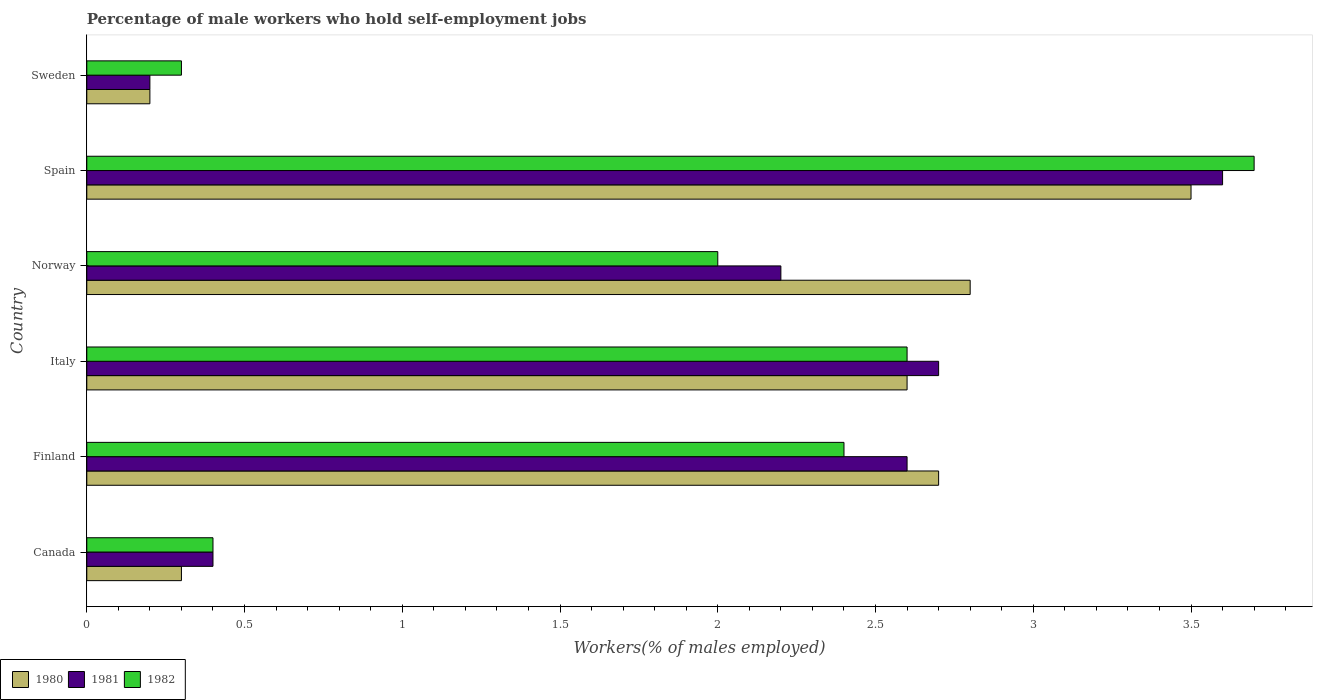How many groups of bars are there?
Give a very brief answer. 6. Are the number of bars per tick equal to the number of legend labels?
Ensure brevity in your answer.  Yes. How many bars are there on the 4th tick from the bottom?
Offer a very short reply. 3. Across all countries, what is the minimum percentage of self-employed male workers in 1980?
Your response must be concise. 0.2. In which country was the percentage of self-employed male workers in 1982 maximum?
Offer a very short reply. Spain. What is the total percentage of self-employed male workers in 1981 in the graph?
Keep it short and to the point. 11.7. What is the difference between the percentage of self-employed male workers in 1980 in Norway and that in Sweden?
Offer a terse response. 2.6. What is the difference between the percentage of self-employed male workers in 1981 in Canada and the percentage of self-employed male workers in 1980 in Sweden?
Your response must be concise. 0.2. What is the average percentage of self-employed male workers in 1981 per country?
Give a very brief answer. 1.95. What is the difference between the percentage of self-employed male workers in 1980 and percentage of self-employed male workers in 1981 in Norway?
Your answer should be very brief. 0.6. In how many countries, is the percentage of self-employed male workers in 1980 greater than 3.6 %?
Keep it short and to the point. 0. What is the ratio of the percentage of self-employed male workers in 1982 in Finland to that in Norway?
Keep it short and to the point. 1.2. What is the difference between the highest and the second highest percentage of self-employed male workers in 1981?
Give a very brief answer. 0.9. What is the difference between the highest and the lowest percentage of self-employed male workers in 1982?
Ensure brevity in your answer.  3.4. In how many countries, is the percentage of self-employed male workers in 1981 greater than the average percentage of self-employed male workers in 1981 taken over all countries?
Your answer should be very brief. 4. What does the 2nd bar from the bottom in Spain represents?
Give a very brief answer. 1981. Is it the case that in every country, the sum of the percentage of self-employed male workers in 1982 and percentage of self-employed male workers in 1980 is greater than the percentage of self-employed male workers in 1981?
Offer a very short reply. Yes. How many bars are there?
Your answer should be very brief. 18. Are all the bars in the graph horizontal?
Keep it short and to the point. Yes. What is the difference between two consecutive major ticks on the X-axis?
Provide a succinct answer. 0.5. Are the values on the major ticks of X-axis written in scientific E-notation?
Ensure brevity in your answer.  No. Does the graph contain any zero values?
Give a very brief answer. No. Where does the legend appear in the graph?
Offer a terse response. Bottom left. How many legend labels are there?
Ensure brevity in your answer.  3. How are the legend labels stacked?
Provide a succinct answer. Horizontal. What is the title of the graph?
Offer a terse response. Percentage of male workers who hold self-employment jobs. Does "1976" appear as one of the legend labels in the graph?
Your answer should be very brief. No. What is the label or title of the X-axis?
Offer a very short reply. Workers(% of males employed). What is the Workers(% of males employed) in 1980 in Canada?
Keep it short and to the point. 0.3. What is the Workers(% of males employed) of 1981 in Canada?
Your answer should be compact. 0.4. What is the Workers(% of males employed) of 1982 in Canada?
Keep it short and to the point. 0.4. What is the Workers(% of males employed) of 1980 in Finland?
Provide a short and direct response. 2.7. What is the Workers(% of males employed) in 1981 in Finland?
Offer a terse response. 2.6. What is the Workers(% of males employed) in 1982 in Finland?
Give a very brief answer. 2.4. What is the Workers(% of males employed) of 1980 in Italy?
Provide a short and direct response. 2.6. What is the Workers(% of males employed) of 1981 in Italy?
Offer a terse response. 2.7. What is the Workers(% of males employed) of 1982 in Italy?
Your answer should be very brief. 2.6. What is the Workers(% of males employed) of 1980 in Norway?
Provide a succinct answer. 2.8. What is the Workers(% of males employed) of 1981 in Norway?
Your answer should be very brief. 2.2. What is the Workers(% of males employed) of 1982 in Norway?
Make the answer very short. 2. What is the Workers(% of males employed) of 1980 in Spain?
Provide a succinct answer. 3.5. What is the Workers(% of males employed) in 1981 in Spain?
Offer a very short reply. 3.6. What is the Workers(% of males employed) in 1982 in Spain?
Give a very brief answer. 3.7. What is the Workers(% of males employed) of 1980 in Sweden?
Your answer should be very brief. 0.2. What is the Workers(% of males employed) of 1981 in Sweden?
Offer a very short reply. 0.2. What is the Workers(% of males employed) in 1982 in Sweden?
Your answer should be very brief. 0.3. Across all countries, what is the maximum Workers(% of males employed) in 1981?
Your answer should be very brief. 3.6. Across all countries, what is the maximum Workers(% of males employed) of 1982?
Keep it short and to the point. 3.7. Across all countries, what is the minimum Workers(% of males employed) in 1980?
Give a very brief answer. 0.2. Across all countries, what is the minimum Workers(% of males employed) of 1981?
Provide a short and direct response. 0.2. Across all countries, what is the minimum Workers(% of males employed) in 1982?
Keep it short and to the point. 0.3. What is the total Workers(% of males employed) in 1980 in the graph?
Give a very brief answer. 12.1. What is the total Workers(% of males employed) of 1982 in the graph?
Your response must be concise. 11.4. What is the difference between the Workers(% of males employed) of 1980 in Canada and that in Finland?
Offer a very short reply. -2.4. What is the difference between the Workers(% of males employed) of 1982 in Canada and that in Finland?
Your response must be concise. -2. What is the difference between the Workers(% of males employed) of 1981 in Canada and that in Italy?
Keep it short and to the point. -2.3. What is the difference between the Workers(% of males employed) of 1981 in Canada and that in Norway?
Give a very brief answer. -1.8. What is the difference between the Workers(% of males employed) of 1982 in Canada and that in Norway?
Your response must be concise. -1.6. What is the difference between the Workers(% of males employed) of 1980 in Canada and that in Spain?
Keep it short and to the point. -3.2. What is the difference between the Workers(% of males employed) in 1980 in Finland and that in Italy?
Provide a succinct answer. 0.1. What is the difference between the Workers(% of males employed) in 1981 in Finland and that in Italy?
Provide a succinct answer. -0.1. What is the difference between the Workers(% of males employed) in 1982 in Finland and that in Italy?
Your answer should be very brief. -0.2. What is the difference between the Workers(% of males employed) of 1980 in Finland and that in Norway?
Provide a short and direct response. -0.1. What is the difference between the Workers(% of males employed) in 1981 in Finland and that in Norway?
Provide a succinct answer. 0.4. What is the difference between the Workers(% of males employed) in 1981 in Finland and that in Spain?
Provide a short and direct response. -1. What is the difference between the Workers(% of males employed) in 1980 in Finland and that in Sweden?
Make the answer very short. 2.5. What is the difference between the Workers(% of males employed) of 1980 in Italy and that in Norway?
Your answer should be very brief. -0.2. What is the difference between the Workers(% of males employed) of 1981 in Italy and that in Norway?
Give a very brief answer. 0.5. What is the difference between the Workers(% of males employed) in 1980 in Italy and that in Spain?
Your response must be concise. -0.9. What is the difference between the Workers(% of males employed) in 1981 in Italy and that in Sweden?
Offer a very short reply. 2.5. What is the difference between the Workers(% of males employed) in 1980 in Norway and that in Spain?
Offer a terse response. -0.7. What is the difference between the Workers(% of males employed) of 1981 in Norway and that in Spain?
Provide a short and direct response. -1.4. What is the difference between the Workers(% of males employed) in 1982 in Norway and that in Spain?
Offer a very short reply. -1.7. What is the difference between the Workers(% of males employed) of 1981 in Norway and that in Sweden?
Offer a terse response. 2. What is the difference between the Workers(% of males employed) in 1980 in Canada and the Workers(% of males employed) in 1982 in Finland?
Make the answer very short. -2.1. What is the difference between the Workers(% of males employed) of 1981 in Canada and the Workers(% of males employed) of 1982 in Finland?
Your answer should be compact. -2. What is the difference between the Workers(% of males employed) in 1980 in Canada and the Workers(% of males employed) in 1982 in Norway?
Your answer should be compact. -1.7. What is the difference between the Workers(% of males employed) of 1981 in Canada and the Workers(% of males employed) of 1982 in Norway?
Ensure brevity in your answer.  -1.6. What is the difference between the Workers(% of males employed) of 1980 in Canada and the Workers(% of males employed) of 1982 in Spain?
Make the answer very short. -3.4. What is the difference between the Workers(% of males employed) in 1980 in Canada and the Workers(% of males employed) in 1982 in Sweden?
Provide a short and direct response. 0. What is the difference between the Workers(% of males employed) of 1980 in Finland and the Workers(% of males employed) of 1981 in Italy?
Give a very brief answer. 0. What is the difference between the Workers(% of males employed) of 1981 in Finland and the Workers(% of males employed) of 1982 in Norway?
Give a very brief answer. 0.6. What is the difference between the Workers(% of males employed) in 1980 in Finland and the Workers(% of males employed) in 1981 in Spain?
Provide a succinct answer. -0.9. What is the difference between the Workers(% of males employed) in 1980 in Finland and the Workers(% of males employed) in 1982 in Spain?
Your response must be concise. -1. What is the difference between the Workers(% of males employed) of 1980 in Finland and the Workers(% of males employed) of 1981 in Sweden?
Your answer should be compact. 2.5. What is the difference between the Workers(% of males employed) in 1981 in Finland and the Workers(% of males employed) in 1982 in Sweden?
Provide a succinct answer. 2.3. What is the difference between the Workers(% of males employed) in 1980 in Italy and the Workers(% of males employed) in 1981 in Norway?
Your response must be concise. 0.4. What is the difference between the Workers(% of males employed) in 1981 in Italy and the Workers(% of males employed) in 1982 in Spain?
Your answer should be compact. -1. What is the difference between the Workers(% of males employed) in 1980 in Italy and the Workers(% of males employed) in 1982 in Sweden?
Your answer should be compact. 2.3. What is the difference between the Workers(% of males employed) in 1980 in Norway and the Workers(% of males employed) in 1981 in Spain?
Make the answer very short. -0.8. What is the difference between the Workers(% of males employed) of 1980 in Norway and the Workers(% of males employed) of 1982 in Sweden?
Offer a very short reply. 2.5. What is the difference between the Workers(% of males employed) in 1980 in Spain and the Workers(% of males employed) in 1982 in Sweden?
Keep it short and to the point. 3.2. What is the average Workers(% of males employed) in 1980 per country?
Provide a short and direct response. 2.02. What is the average Workers(% of males employed) in 1981 per country?
Provide a succinct answer. 1.95. What is the difference between the Workers(% of males employed) in 1980 and Workers(% of males employed) in 1981 in Canada?
Make the answer very short. -0.1. What is the difference between the Workers(% of males employed) of 1980 and Workers(% of males employed) of 1981 in Italy?
Make the answer very short. -0.1. What is the difference between the Workers(% of males employed) of 1981 and Workers(% of males employed) of 1982 in Italy?
Make the answer very short. 0.1. What is the difference between the Workers(% of males employed) of 1980 and Workers(% of males employed) of 1982 in Norway?
Provide a succinct answer. 0.8. What is the difference between the Workers(% of males employed) in 1981 and Workers(% of males employed) in 1982 in Sweden?
Make the answer very short. -0.1. What is the ratio of the Workers(% of males employed) in 1980 in Canada to that in Finland?
Your response must be concise. 0.11. What is the ratio of the Workers(% of males employed) of 1981 in Canada to that in Finland?
Give a very brief answer. 0.15. What is the ratio of the Workers(% of males employed) of 1980 in Canada to that in Italy?
Offer a very short reply. 0.12. What is the ratio of the Workers(% of males employed) of 1981 in Canada to that in Italy?
Your answer should be very brief. 0.15. What is the ratio of the Workers(% of males employed) in 1982 in Canada to that in Italy?
Your response must be concise. 0.15. What is the ratio of the Workers(% of males employed) in 1980 in Canada to that in Norway?
Make the answer very short. 0.11. What is the ratio of the Workers(% of males employed) of 1981 in Canada to that in Norway?
Your answer should be compact. 0.18. What is the ratio of the Workers(% of males employed) in 1980 in Canada to that in Spain?
Give a very brief answer. 0.09. What is the ratio of the Workers(% of males employed) of 1981 in Canada to that in Spain?
Your answer should be compact. 0.11. What is the ratio of the Workers(% of males employed) of 1982 in Canada to that in Spain?
Your answer should be very brief. 0.11. What is the ratio of the Workers(% of males employed) of 1980 in Canada to that in Sweden?
Your answer should be compact. 1.5. What is the ratio of the Workers(% of males employed) of 1982 in Canada to that in Sweden?
Your answer should be very brief. 1.33. What is the ratio of the Workers(% of males employed) in 1980 in Finland to that in Italy?
Your answer should be very brief. 1.04. What is the ratio of the Workers(% of males employed) in 1981 in Finland to that in Italy?
Provide a short and direct response. 0.96. What is the ratio of the Workers(% of males employed) of 1982 in Finland to that in Italy?
Keep it short and to the point. 0.92. What is the ratio of the Workers(% of males employed) of 1980 in Finland to that in Norway?
Your answer should be very brief. 0.96. What is the ratio of the Workers(% of males employed) of 1981 in Finland to that in Norway?
Give a very brief answer. 1.18. What is the ratio of the Workers(% of males employed) in 1980 in Finland to that in Spain?
Offer a very short reply. 0.77. What is the ratio of the Workers(% of males employed) of 1981 in Finland to that in Spain?
Your response must be concise. 0.72. What is the ratio of the Workers(% of males employed) of 1982 in Finland to that in Spain?
Your answer should be very brief. 0.65. What is the ratio of the Workers(% of males employed) in 1981 in Finland to that in Sweden?
Your answer should be very brief. 13. What is the ratio of the Workers(% of males employed) of 1980 in Italy to that in Norway?
Offer a terse response. 0.93. What is the ratio of the Workers(% of males employed) of 1981 in Italy to that in Norway?
Provide a short and direct response. 1.23. What is the ratio of the Workers(% of males employed) in 1982 in Italy to that in Norway?
Ensure brevity in your answer.  1.3. What is the ratio of the Workers(% of males employed) of 1980 in Italy to that in Spain?
Ensure brevity in your answer.  0.74. What is the ratio of the Workers(% of males employed) of 1981 in Italy to that in Spain?
Provide a succinct answer. 0.75. What is the ratio of the Workers(% of males employed) of 1982 in Italy to that in Spain?
Provide a short and direct response. 0.7. What is the ratio of the Workers(% of males employed) of 1981 in Italy to that in Sweden?
Keep it short and to the point. 13.5. What is the ratio of the Workers(% of males employed) of 1982 in Italy to that in Sweden?
Offer a terse response. 8.67. What is the ratio of the Workers(% of males employed) of 1981 in Norway to that in Spain?
Offer a terse response. 0.61. What is the ratio of the Workers(% of males employed) of 1982 in Norway to that in Spain?
Your response must be concise. 0.54. What is the ratio of the Workers(% of males employed) in 1980 in Norway to that in Sweden?
Offer a terse response. 14. What is the ratio of the Workers(% of males employed) of 1981 in Norway to that in Sweden?
Offer a very short reply. 11. What is the ratio of the Workers(% of males employed) in 1980 in Spain to that in Sweden?
Provide a short and direct response. 17.5. What is the ratio of the Workers(% of males employed) in 1981 in Spain to that in Sweden?
Keep it short and to the point. 18. What is the ratio of the Workers(% of males employed) of 1982 in Spain to that in Sweden?
Your answer should be very brief. 12.33. What is the difference between the highest and the second highest Workers(% of males employed) of 1981?
Keep it short and to the point. 0.9. What is the difference between the highest and the second highest Workers(% of males employed) in 1982?
Offer a very short reply. 1.1. What is the difference between the highest and the lowest Workers(% of males employed) in 1980?
Your answer should be compact. 3.3. What is the difference between the highest and the lowest Workers(% of males employed) in 1981?
Your answer should be very brief. 3.4. What is the difference between the highest and the lowest Workers(% of males employed) of 1982?
Offer a terse response. 3.4. 